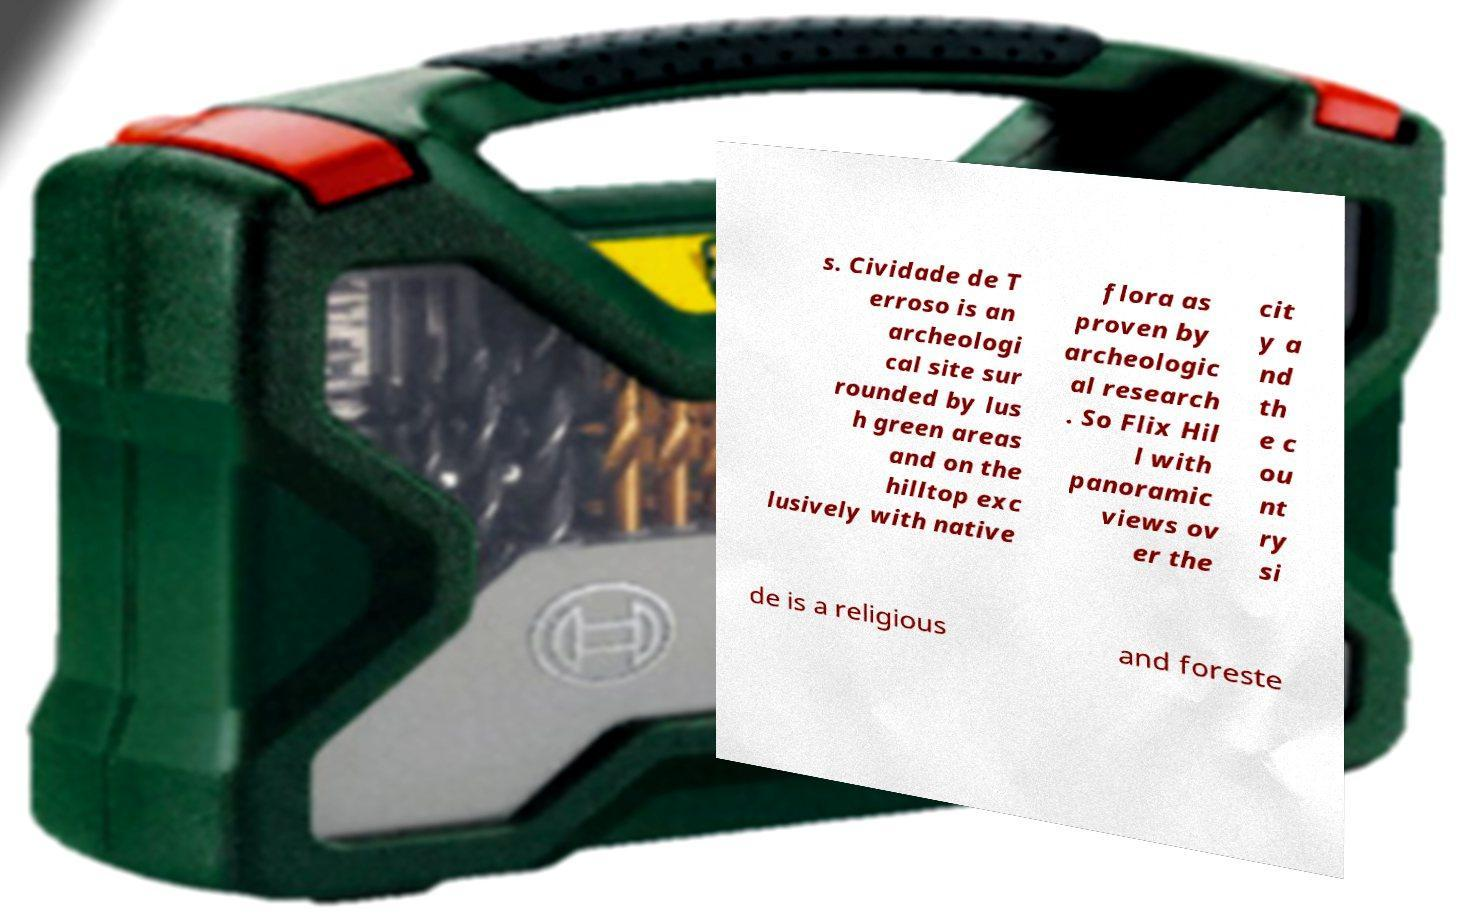I need the written content from this picture converted into text. Can you do that? s. Cividade de T erroso is an archeologi cal site sur rounded by lus h green areas and on the hilltop exc lusively with native flora as proven by archeologic al research . So Flix Hil l with panoramic views ov er the cit y a nd th e c ou nt ry si de is a religious and foreste 